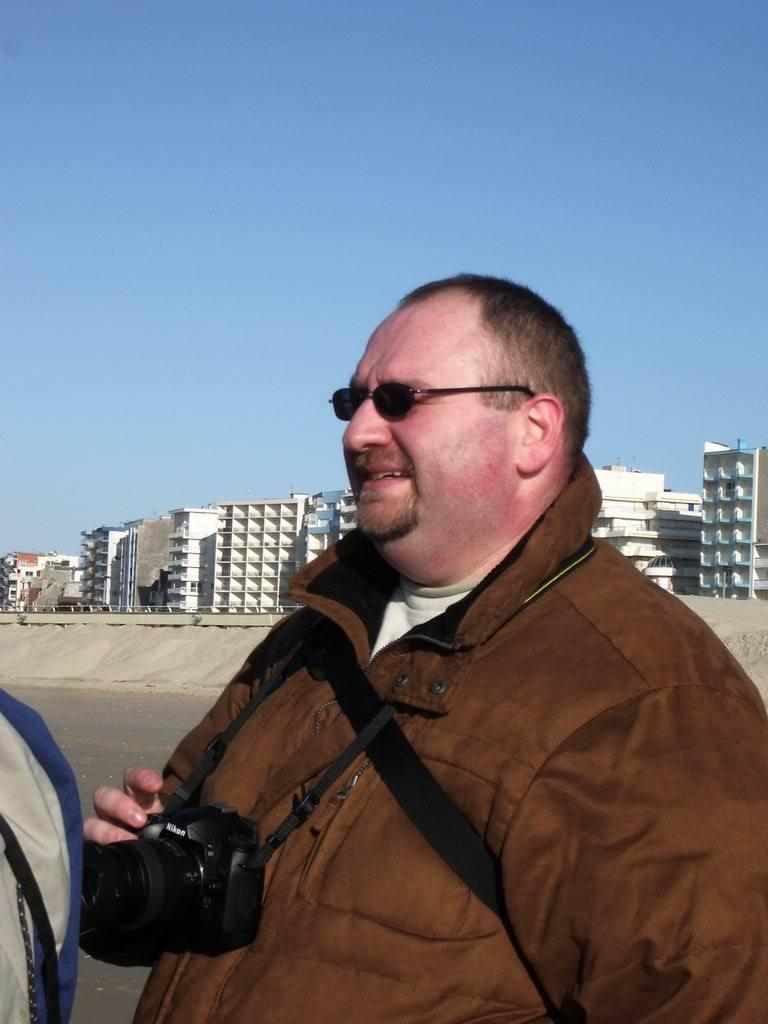Where was the image taken? The image was taken on a road. What is the main subject of the image? There is a man in the center of the image. What is the man wearing? The man is wearing a jacket and spectacles. What is the man holding in the image? The man is holding a camera. What can be seen in the background of the image? There are buildings and the sky visible in the background of the image. What type of milk is being served at the table in the image? There is no table or milk present in the image; it features a man on a road holding a camera. 